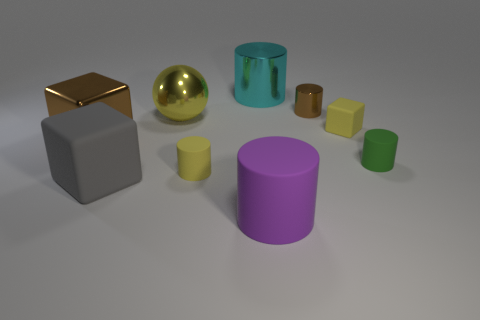Subtract all purple cylinders. How many cylinders are left? 4 Subtract 2 cylinders. How many cylinders are left? 3 Subtract all big metal cylinders. How many cylinders are left? 4 Subtract all gray cylinders. Subtract all blue balls. How many cylinders are left? 5 Add 1 purple things. How many objects exist? 10 Subtract all cylinders. How many objects are left? 4 Add 1 large purple objects. How many large purple objects exist? 2 Subtract 1 yellow cylinders. How many objects are left? 8 Subtract all small yellow things. Subtract all matte cubes. How many objects are left? 5 Add 8 large brown objects. How many large brown objects are left? 9 